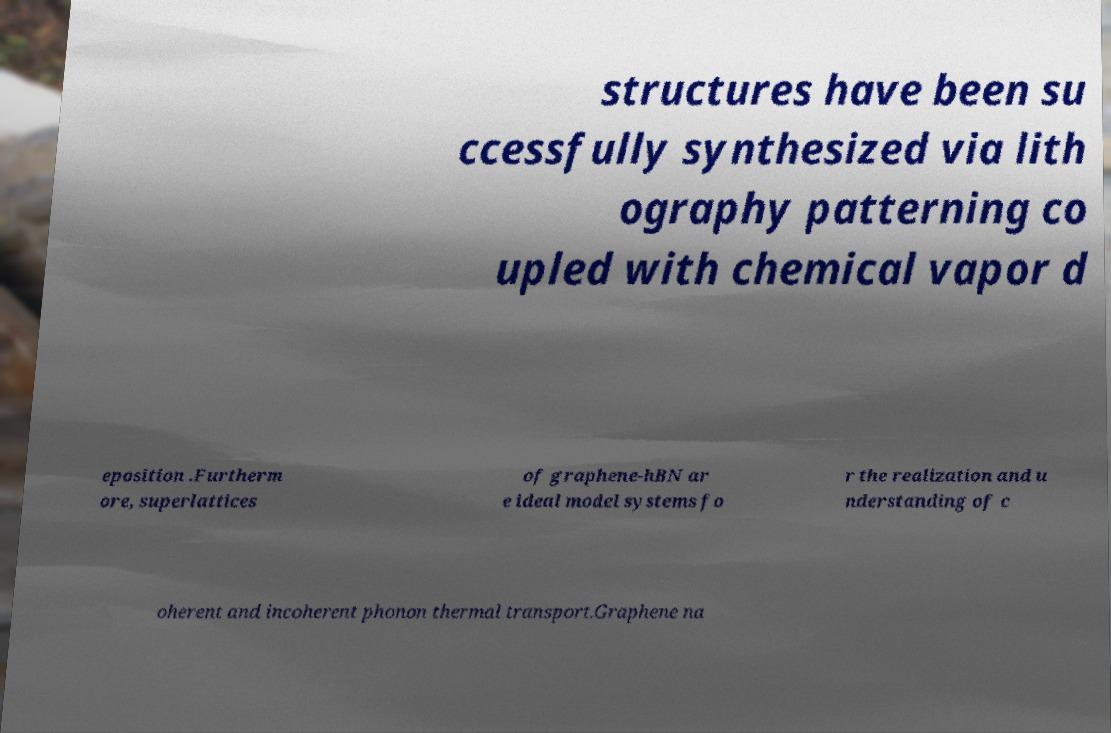Can you accurately transcribe the text from the provided image for me? structures have been su ccessfully synthesized via lith ography patterning co upled with chemical vapor d eposition .Furtherm ore, superlattices of graphene-hBN ar e ideal model systems fo r the realization and u nderstanding of c oherent and incoherent phonon thermal transport.Graphene na 